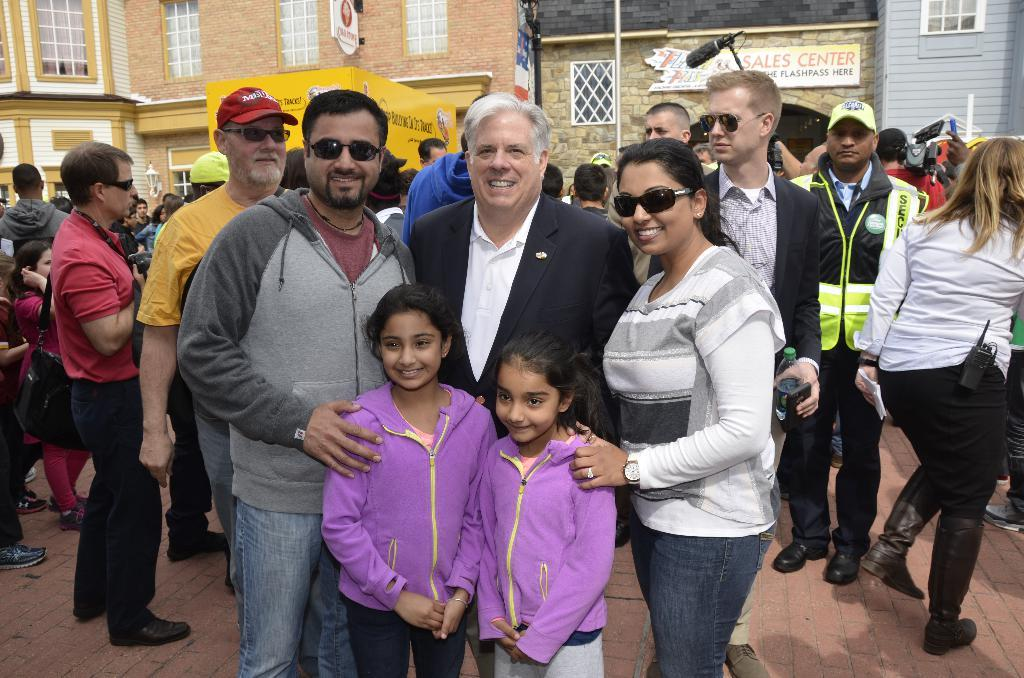How many people are in the image? There is a group of people in the image. What are some of the people doing in the image? Some people are standing, and some people are walking. What can be seen in the background of the image? There is a microphone, hoardings, buildings, and a glass window in the background. How many fifths are present in the image? There is no reference to a fifth in the image, so it is not possible to determine how many fifths might be present. What type of cattle can be seen in the image? There is no cattle present in the image. 